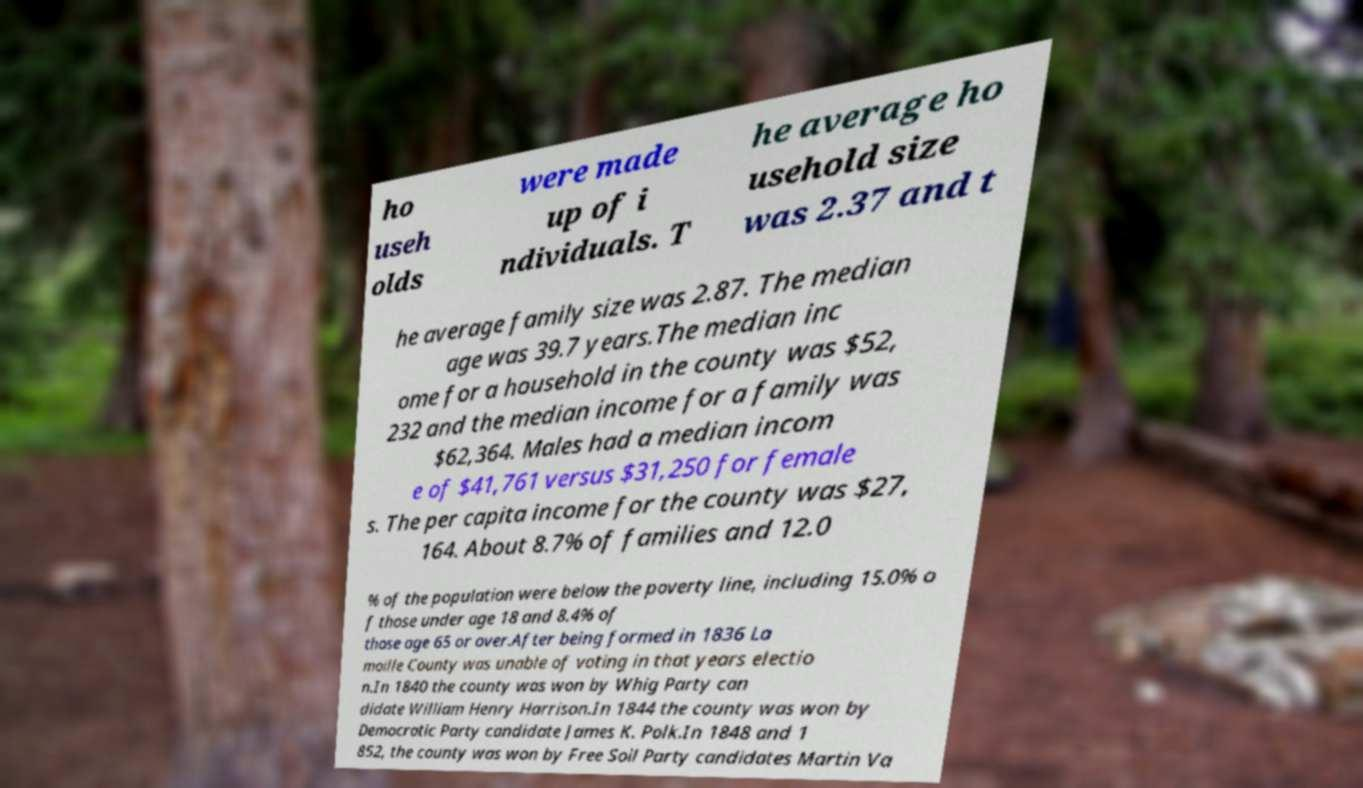Please read and relay the text visible in this image. What does it say? ho useh olds were made up of i ndividuals. T he average ho usehold size was 2.37 and t he average family size was 2.87. The median age was 39.7 years.The median inc ome for a household in the county was $52, 232 and the median income for a family was $62,364. Males had a median incom e of $41,761 versus $31,250 for female s. The per capita income for the county was $27, 164. About 8.7% of families and 12.0 % of the population were below the poverty line, including 15.0% o f those under age 18 and 8.4% of those age 65 or over.After being formed in 1836 La moille County was unable of voting in that years electio n.In 1840 the county was won by Whig Party can didate William Henry Harrison.In 1844 the county was won by Democratic Party candidate James K. Polk.In 1848 and 1 852, the county was won by Free Soil Party candidates Martin Va 